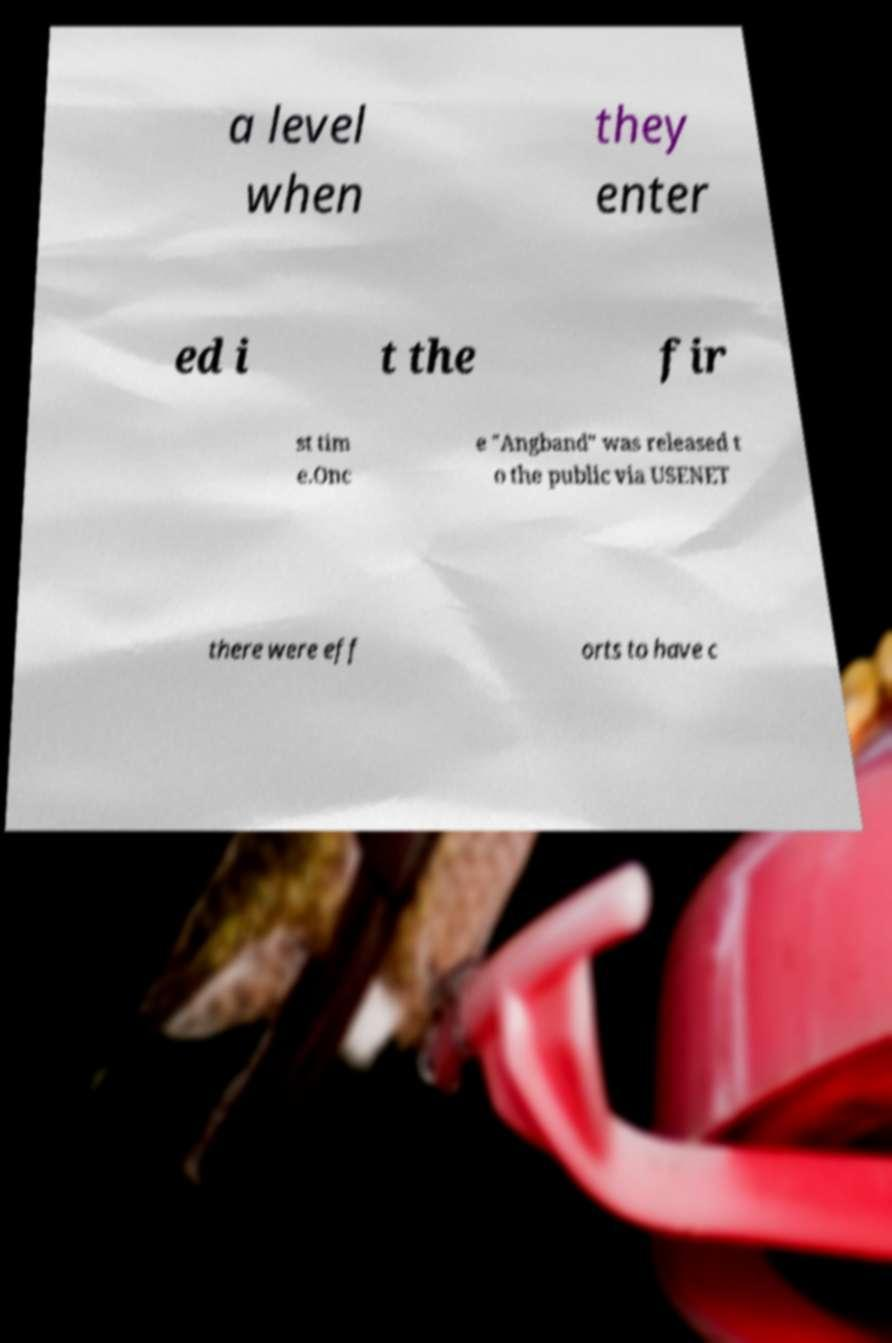Could you extract and type out the text from this image? a level when they enter ed i t the fir st tim e.Onc e "Angband" was released t o the public via USENET there were eff orts to have c 